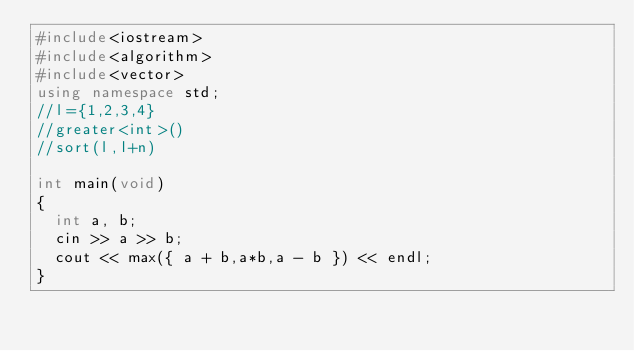<code> <loc_0><loc_0><loc_500><loc_500><_C++_>#include<iostream>
#include<algorithm>
#include<vector>
using namespace std;
//l={1,2,3,4}
//greater<int>()
//sort(l,l+n)

int main(void)
{
	int a, b;
	cin >> a >> b;
	cout << max({ a + b,a*b,a - b }) << endl;
}</code> 